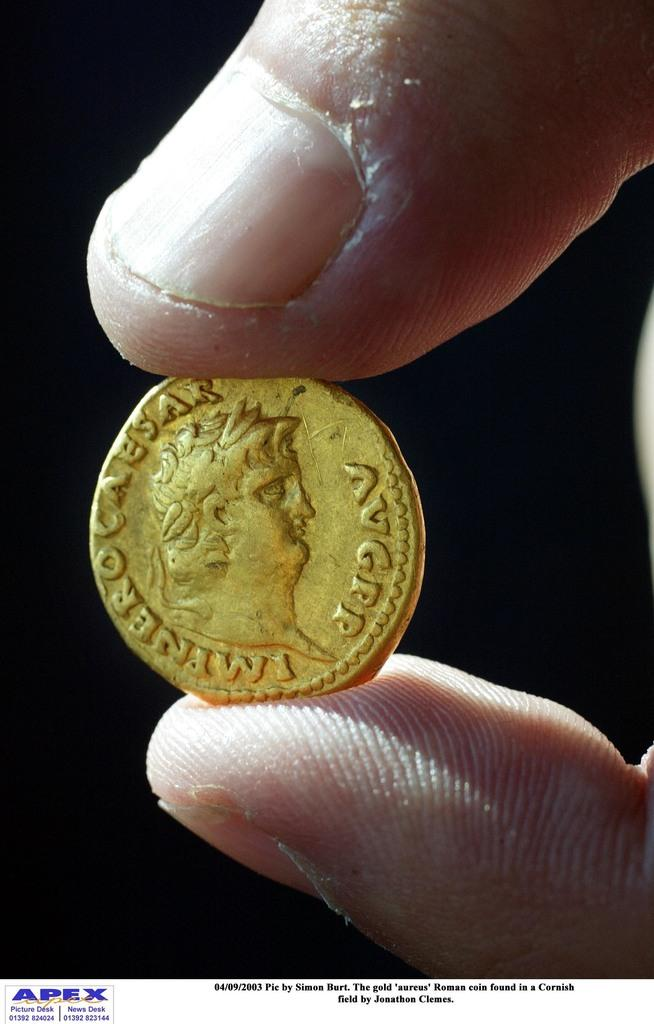<image>
Give a short and clear explanation of the subsequent image. A hand holds an aureus Roman gold coin in this photo dated 04/09/2003 